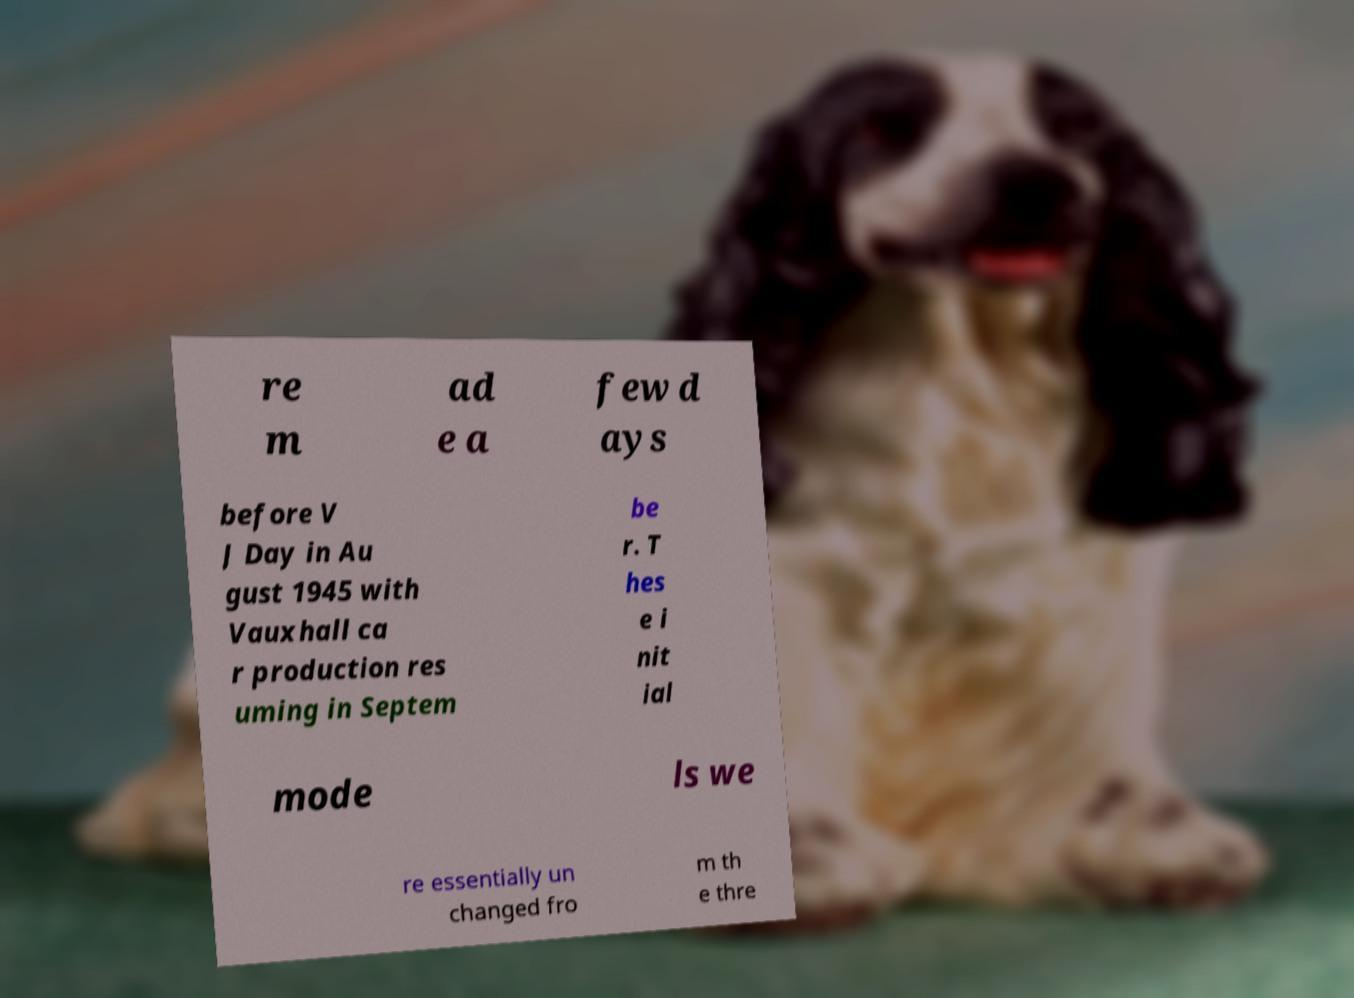There's text embedded in this image that I need extracted. Can you transcribe it verbatim? re m ad e a few d ays before V J Day in Au gust 1945 with Vauxhall ca r production res uming in Septem be r. T hes e i nit ial mode ls we re essentially un changed fro m th e thre 